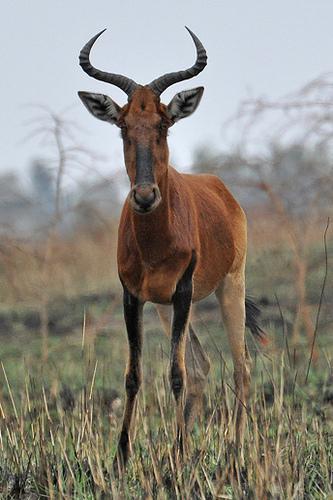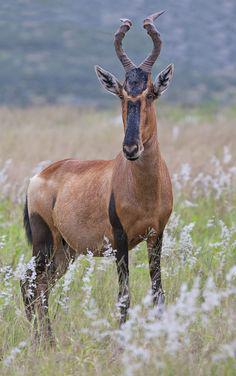The first image is the image on the left, the second image is the image on the right. Evaluate the accuracy of this statement regarding the images: "The horned animal on the left faces the camera directly, although its body is in full profile.". Is it true? Answer yes or no. No. 